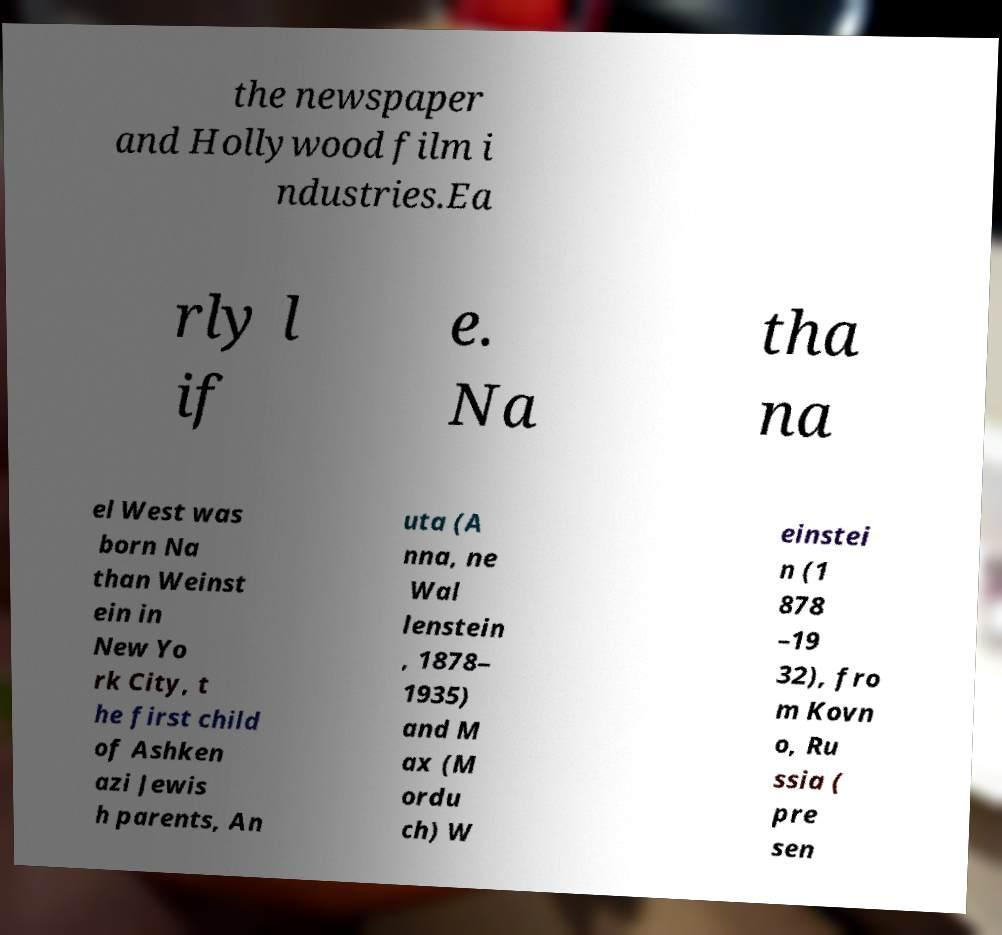There's text embedded in this image that I need extracted. Can you transcribe it verbatim? the newspaper and Hollywood film i ndustries.Ea rly l if e. Na tha na el West was born Na than Weinst ein in New Yo rk City, t he first child of Ashken azi Jewis h parents, An uta (A nna, ne Wal lenstein , 1878– 1935) and M ax (M ordu ch) W einstei n (1 878 –19 32), fro m Kovn o, Ru ssia ( pre sen 